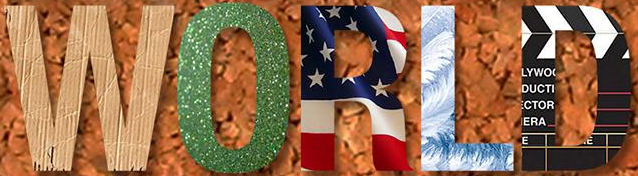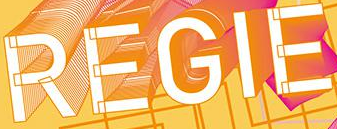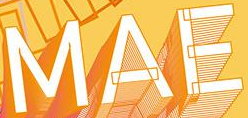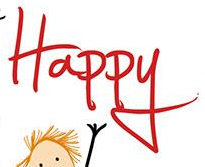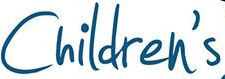Transcribe the words shown in these images in order, separated by a semicolon. WORLD; REGIE; MAE; Happy; Children's 